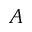Convert formula to latex. <formula><loc_0><loc_0><loc_500><loc_500>A</formula> 